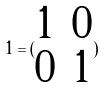<formula> <loc_0><loc_0><loc_500><loc_500>1 = ( \begin{matrix} 1 & 0 \\ 0 & 1 \end{matrix} )</formula> 